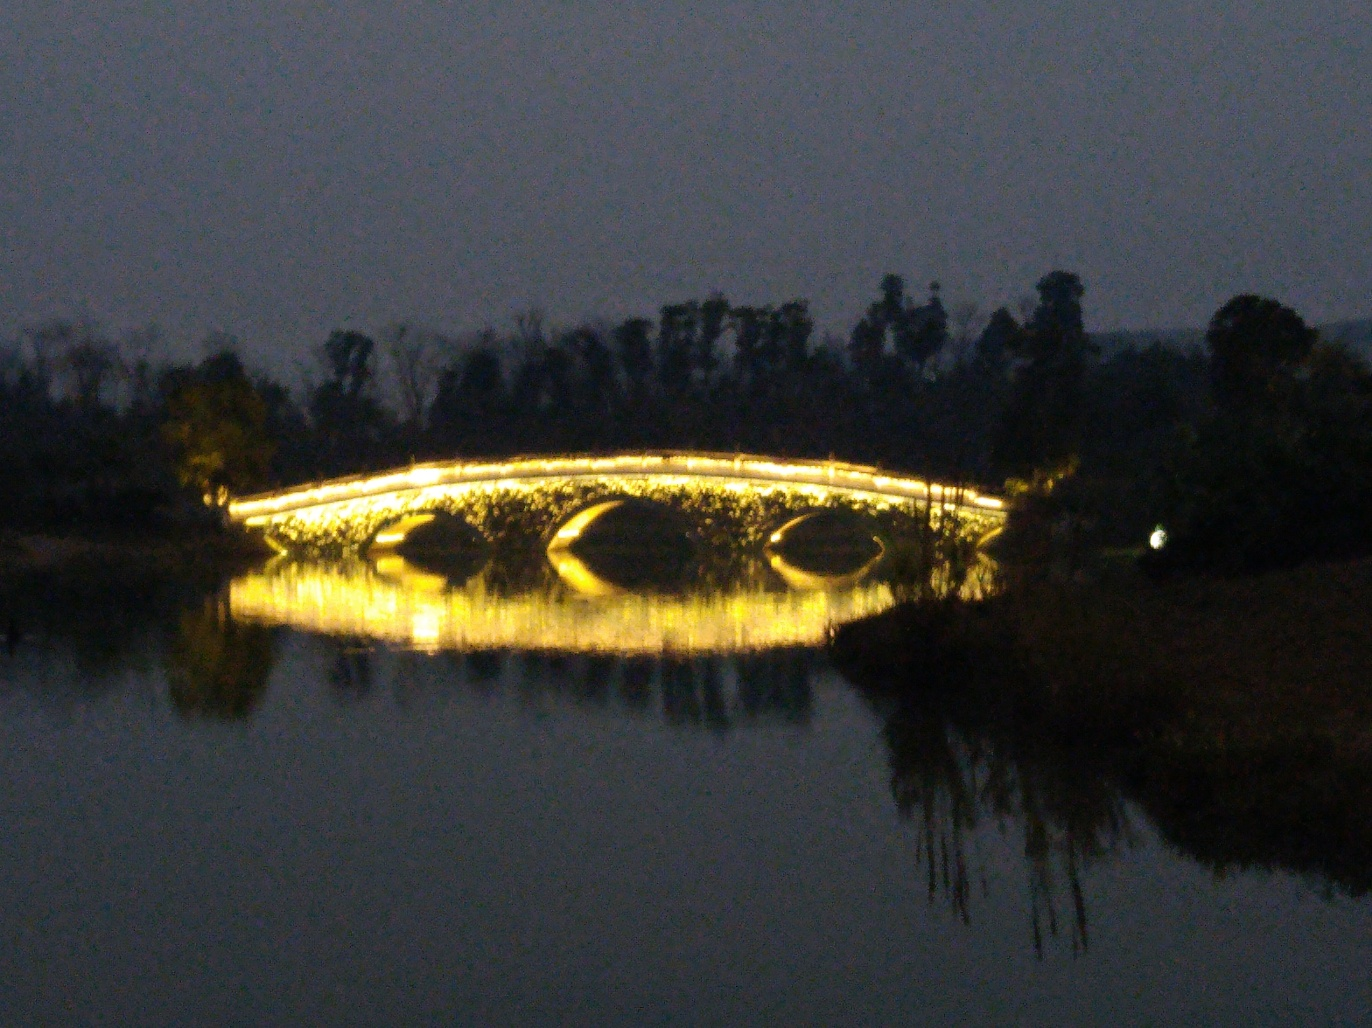Explain the potential impact of this bridge on the local environment and community. The illuminated bridge serves not just as infrastructure but likely as a social hub, drawing people together in the evenings for recreation and relaxation. Environmentally, the light pollution is minimal, but care must be taken to ensure that wildlife in the area is not adversely affected. This bridge, by creating a focal point of beauty, can have a positive impact on community pride and cohesion. 